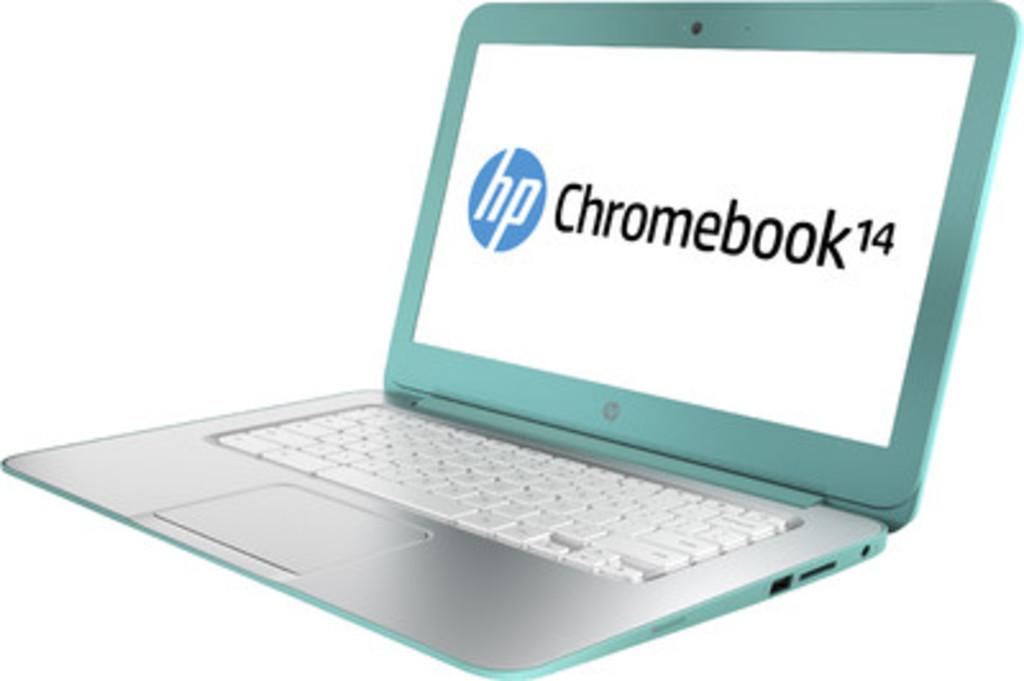What brand is the laptop?
Your answer should be compact. Hp. What number series is this chromebook?
Give a very brief answer. 14. 